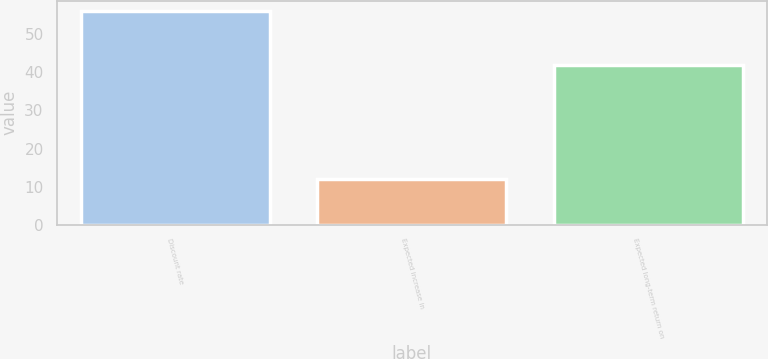Convert chart to OTSL. <chart><loc_0><loc_0><loc_500><loc_500><bar_chart><fcel>Discount rate<fcel>Expected increase in<fcel>Expected long-term return on<nl><fcel>56<fcel>12<fcel>42<nl></chart> 